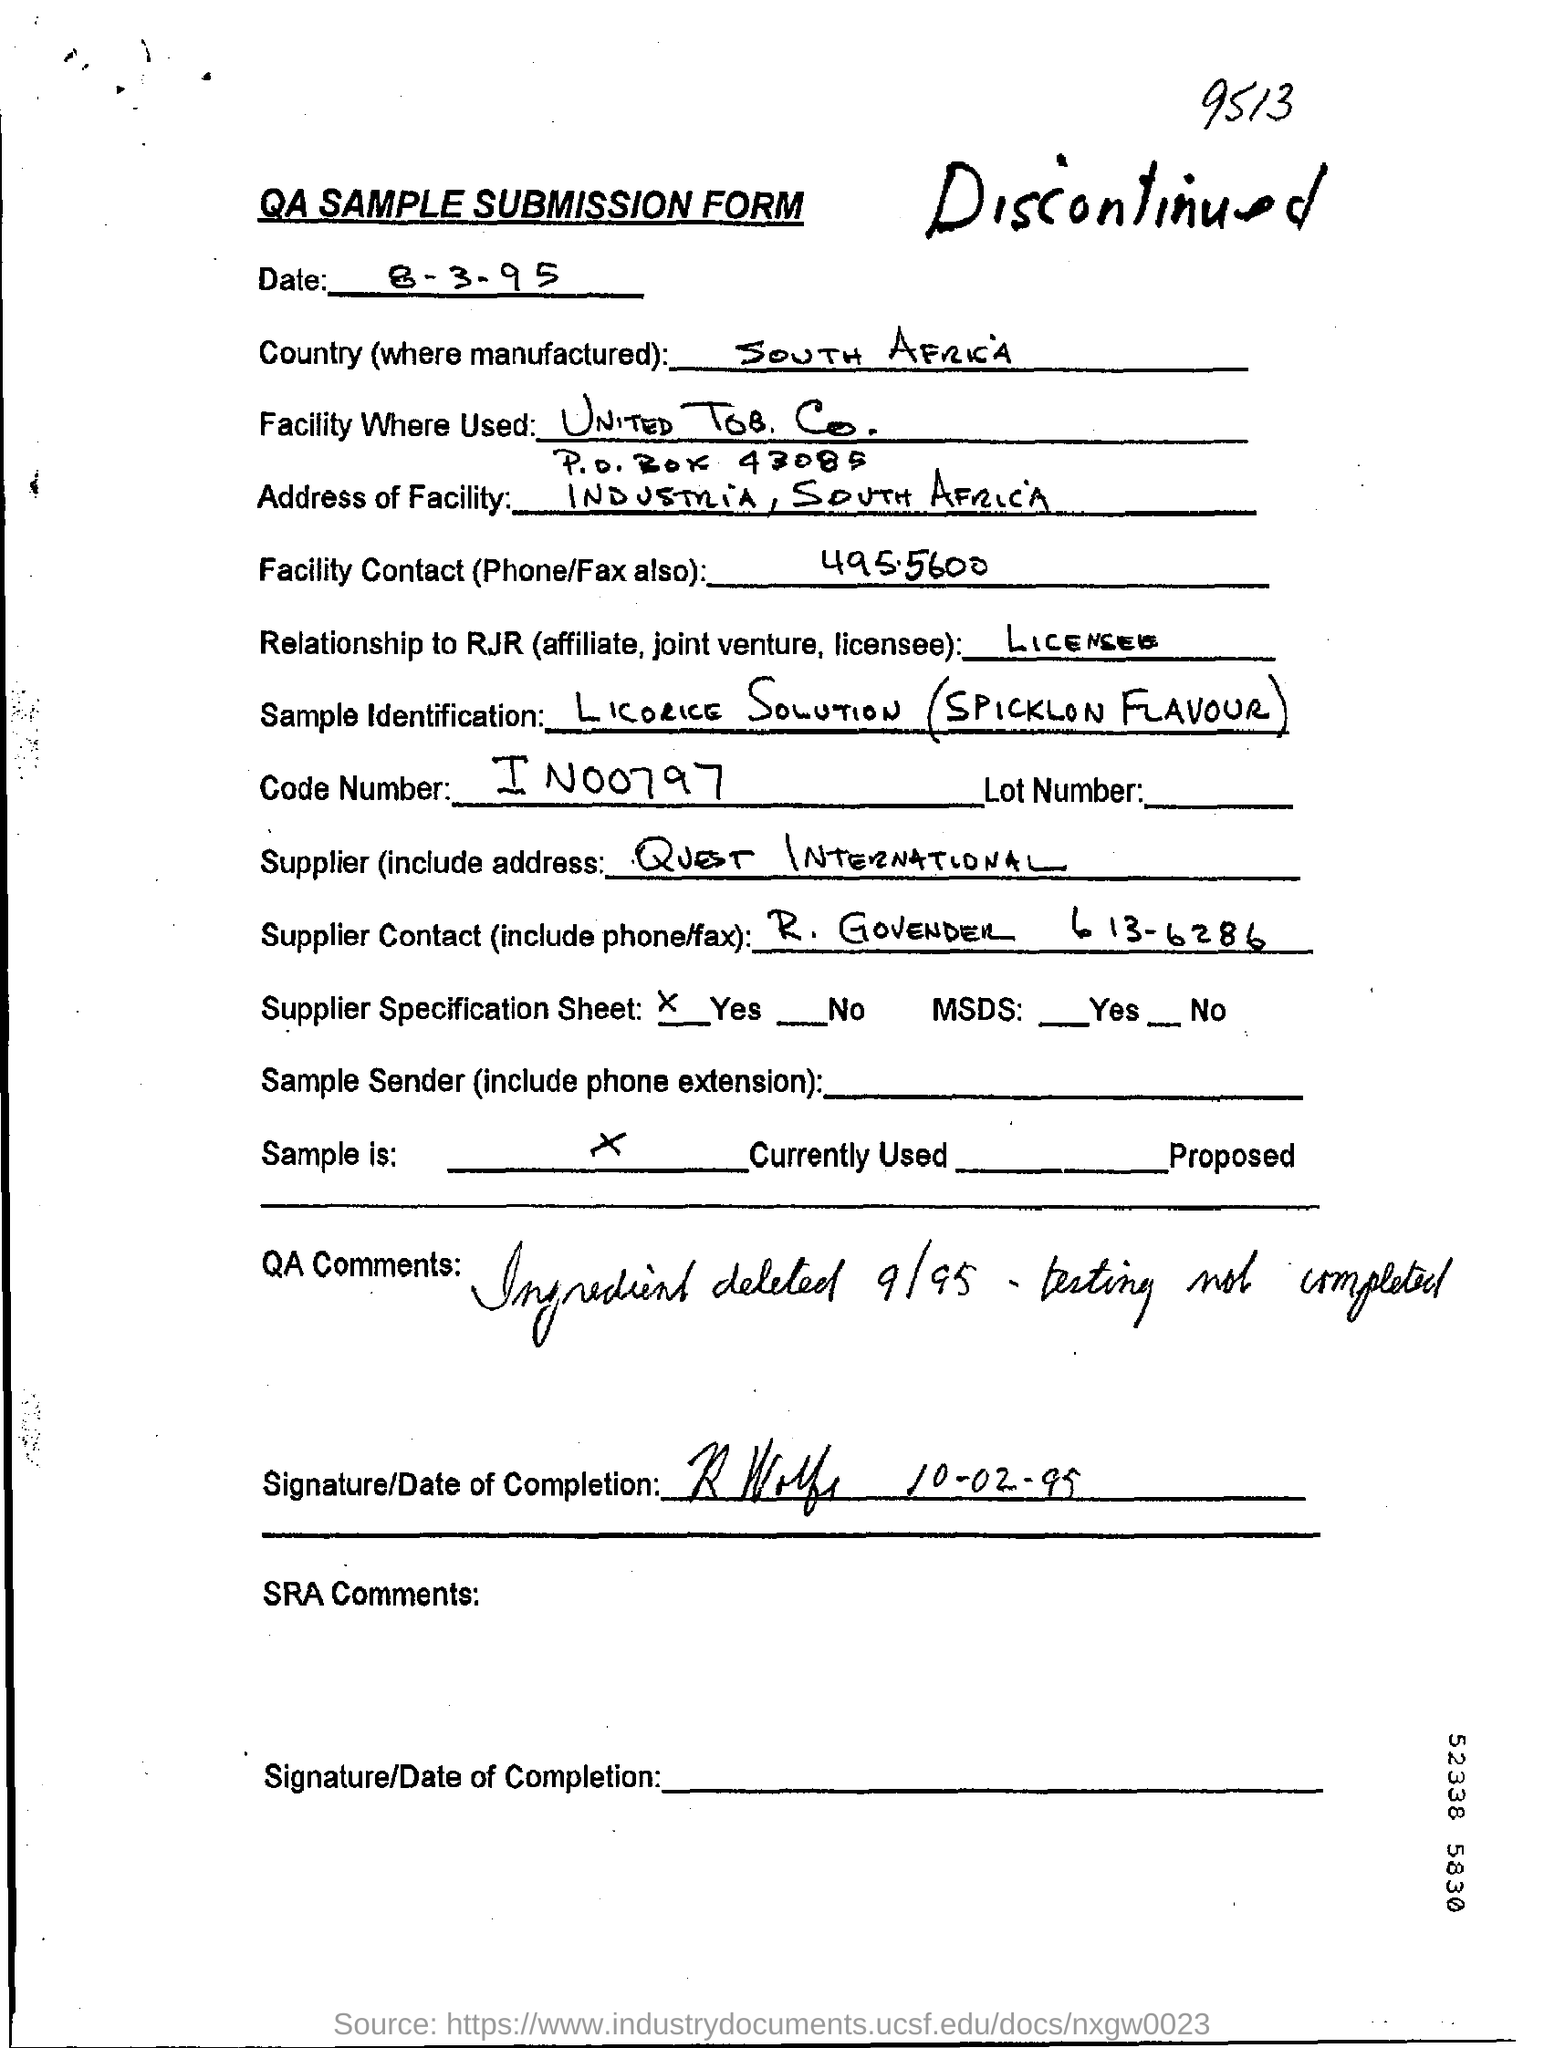Outline some significant characteristics in this image. IN00797 is the code number. The country mentioned in the form is South Africa. The date mentioned is 8-3-95. 